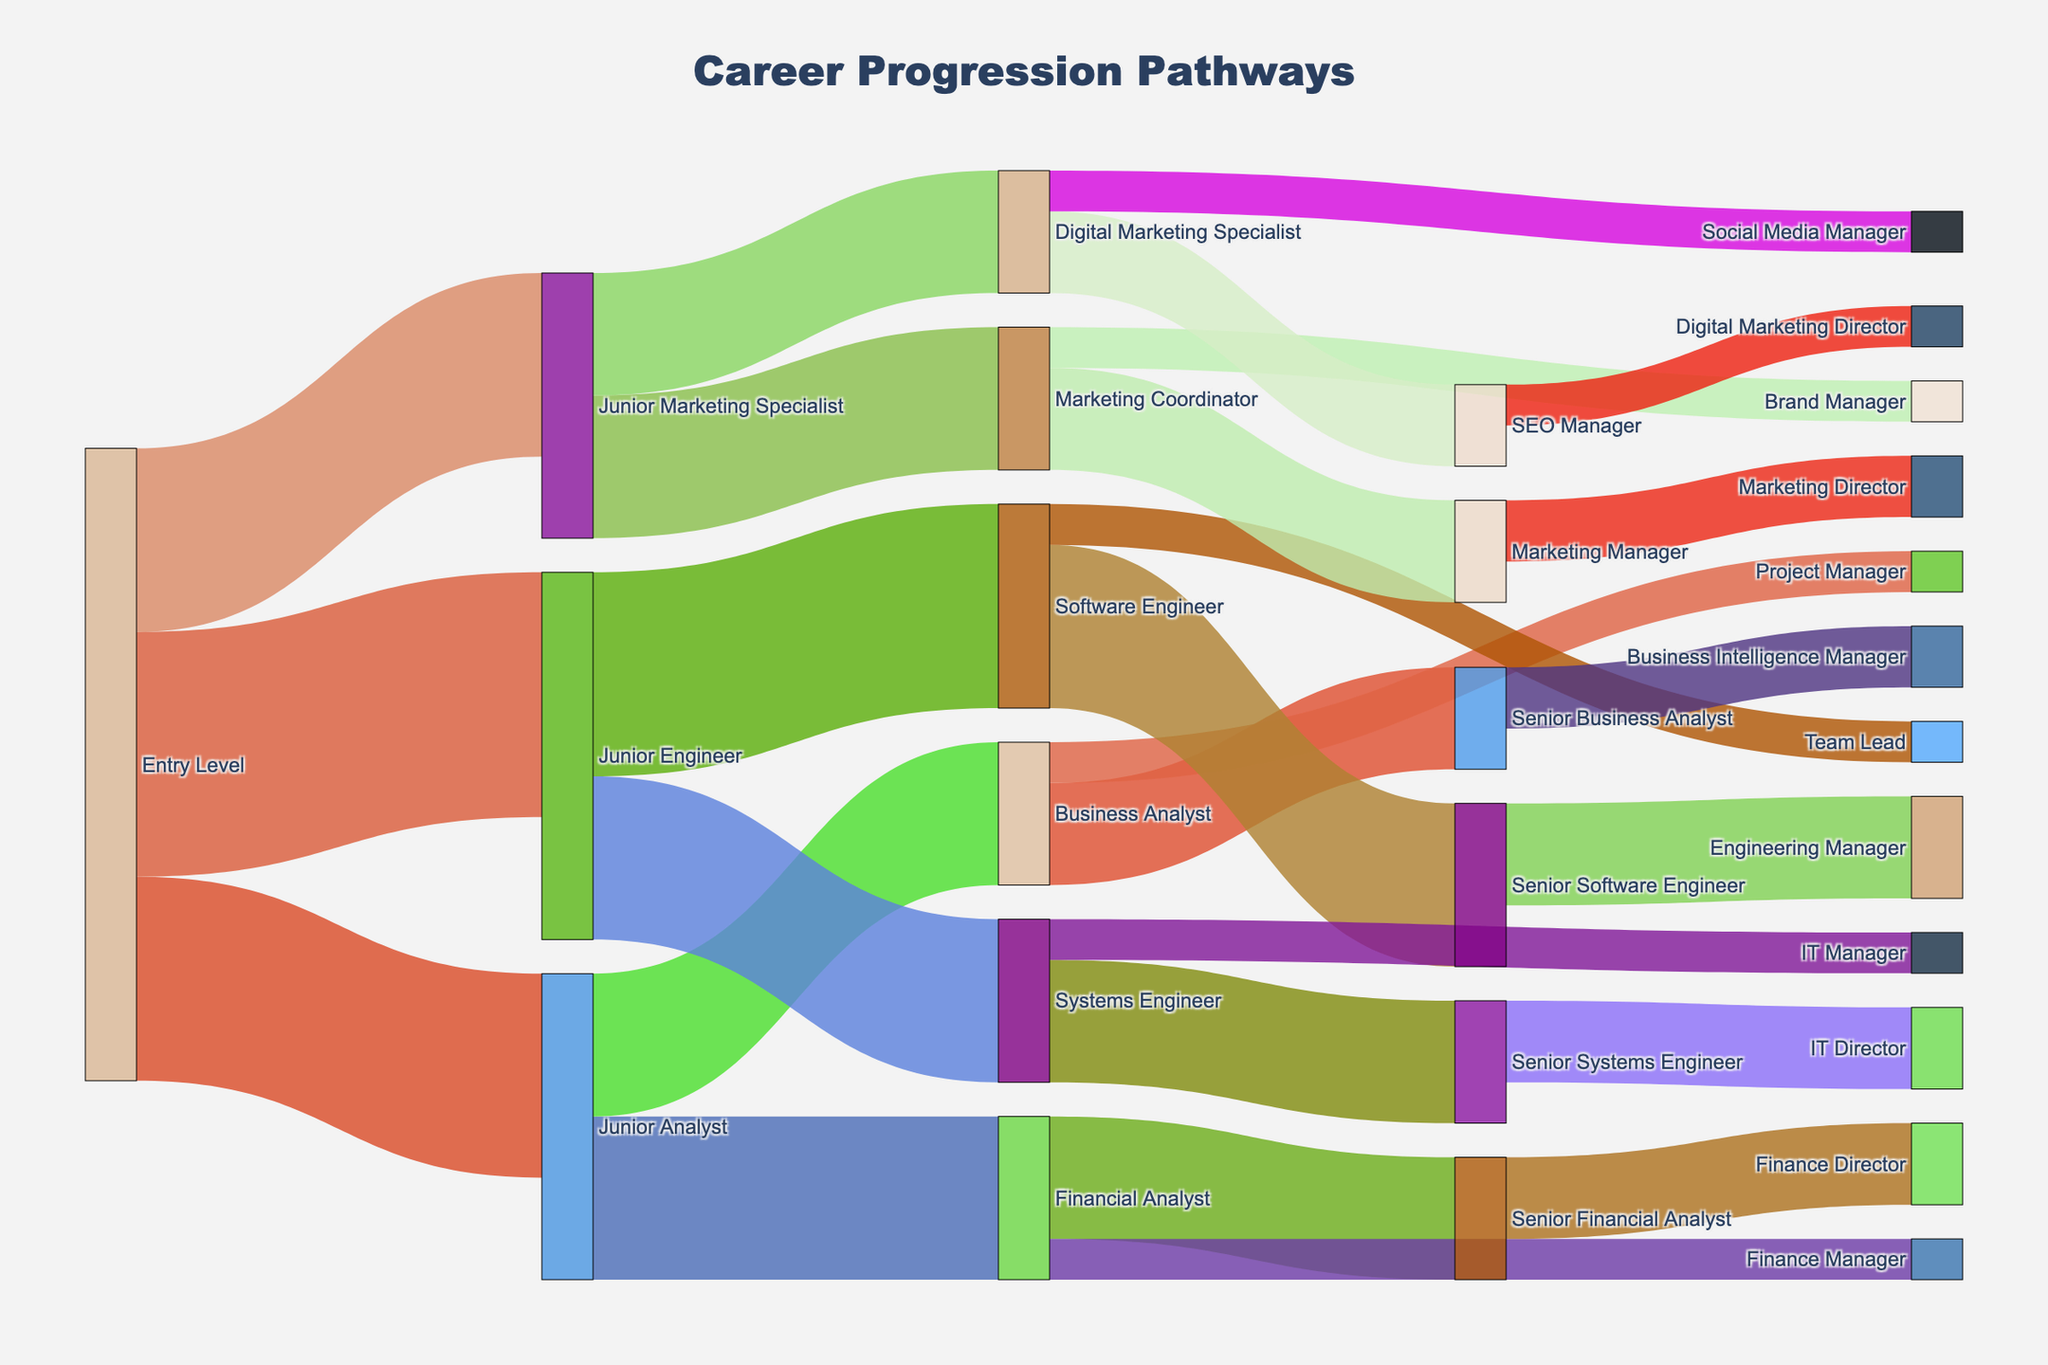what is the career progression pathway from 'Entry Level' to 'Marketing Director'? Starting from 'Entry Level', the pathway to 'Marketing Director' typically goes through 'Junior Marketing Specialist', then 'Marketing Coordinator', followed by 'Marketing Manager', and finally to 'Marketing Director'.
Answer: 'Entry Level' → 'Junior Marketing Specialist' → 'Marketing Coordinator' → 'Marketing Manager' → 'Marketing Director' how many employees move from 'Junior Engineer' to 'Software Engineer'? The Sankey Diagram shows a flow of 100 employees moving from 'Junior Engineer' to 'Software Engineer'.
Answer: 100 Which role receives the highest number of employees transitioning from 'Junior Analyst'? The highest number of employees transition from 'Junior Analyst' to 'Financial Analyst' at 80.
Answer: 'Financial Analyst' what's the total number of employees transitioning from 'Financial Analyst'? The total number of employees transitioning from 'Financial Analyst' is calculated by summing 60 (to 'Senior Financial Analyst') and 20 (to 'Finance Manager'), resulting in a total of 80.
Answer: 80 how does the transition from 'Senior Software Engineer' split between different target roles? From the 'Senior Software Engineer' role, 50 employees move to 'Engineering Manager' and none to any other roles, resulting in a split of 50.
Answer: 'Engineering Manager' what's the least common career progression path starting from 'Entry Level'? The 'Entry Level' to 'Junior Marketing Specialist' to 'Digital Marketing Specialist' to 'Social Media Manager' pathway shows the least number of employees transitioning, with just 60 in total at 'Digital Marketing Specialist' and 20 at 'Social Media Manager'.
Answer: 'Entry Level' → 'Junior Marketing Specialist' → 'Digital Marketing Specialist' → 'Social Media Manager' Which two roles have the same highest number of employees transitioning to them? Both 'Software Engineer' and 'Junior Engineer' have the highest number of 100 employees transitioning to them from 'Junior Engineer' and 'Entry Level' respectively.
Answer: 'Software Engineer' and 'Junior Engineer' what are the career options for a 'Business Analyst'? The 'Business Analyst' can transition to 'Senior Business Analyst' or 'Project Manager' with employee numbers being 50 and 20 respectively.
Answer: 'Senior Business Analyst' or 'Project Manager' how many employees progress from 'Digital Marketing Specialist' to 'SEO Manager' compared to 'Social Media Manager'? 40 employees progress to 'SEO Manager', while only 20 move to 'Social Media Manager'.
Answer: 40 to 'SEO Manager' and 20 to 'Social Media Manager' 